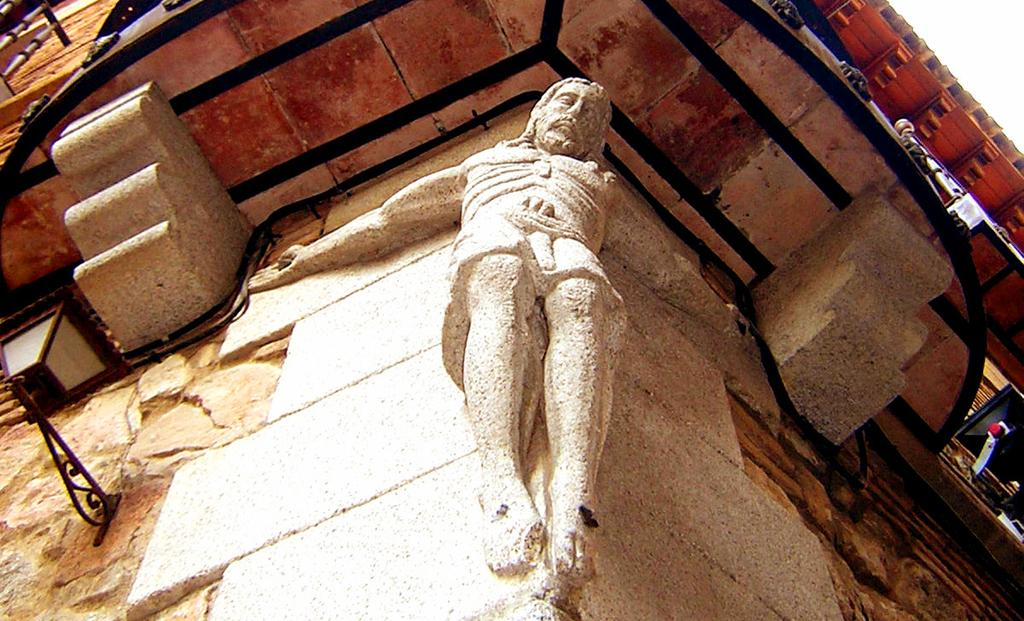What is the main subject in the foreground of the image? There is a sculpture on a wall in the foreground of the image. What other objects can be seen in the image? There is a lamp on the left side of the image. What type of structure does the image appear to depict? The image appears to depict a building. How many boats are visible in the image? There are no boats present in the image. What type of harmony is depicted in the image? The image does not depict any harmony; it features a sculpture on a wall and a lamp in a building setting. 